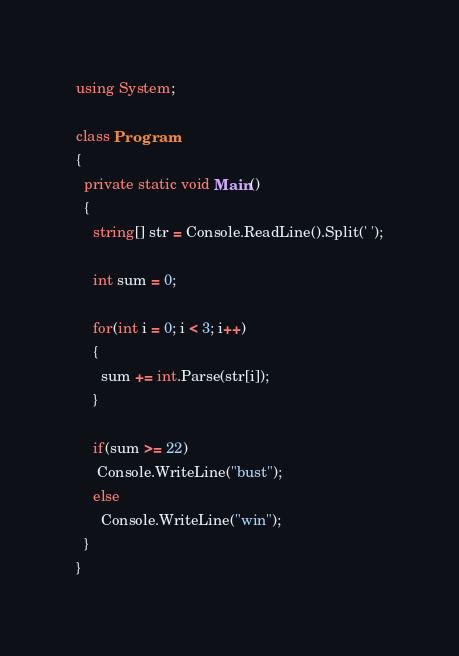Convert code to text. <code><loc_0><loc_0><loc_500><loc_500><_C#_>using System;

class Program
{
  private static void Main()
  {
    string[] str = Console.ReadLine().Split(' ');
    
    int sum = 0;
    
    for(int i = 0; i < 3; i++)
    {
      sum += int.Parse(str[i]);
    }
    
    if(sum >= 22)
     Console.WriteLine("bust");
    else
      Console.WriteLine("win");
  }
}
</code> 